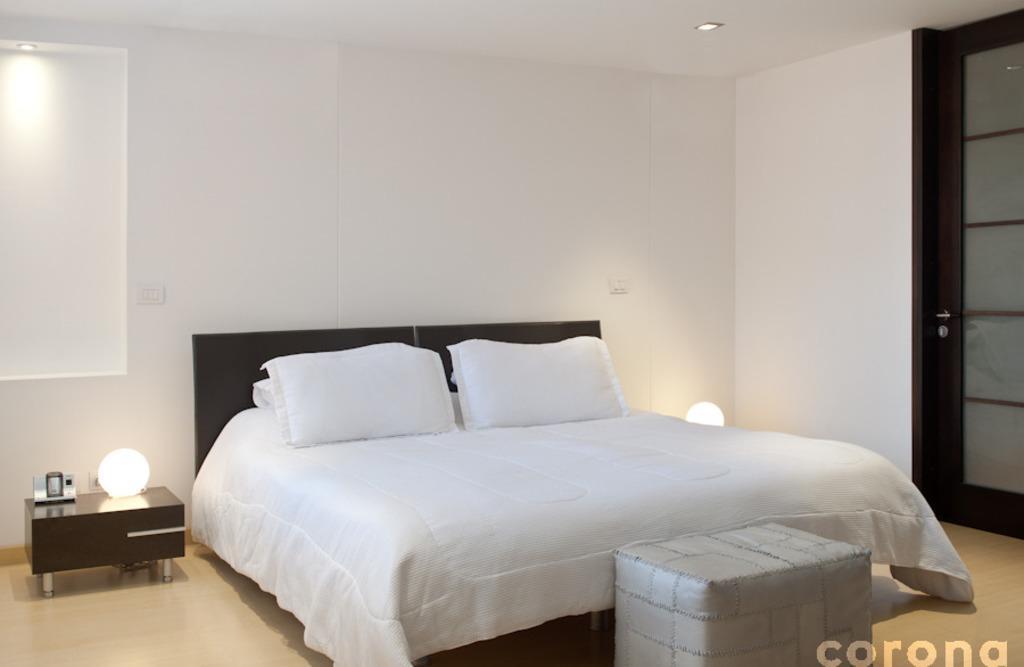In one or two sentences, can you explain what this image depicts? In this image I can see bed in white color and two pillows on the bed, they are also in white color. At left and right I can see two lamps on the table, at the background the wall is in white color. 